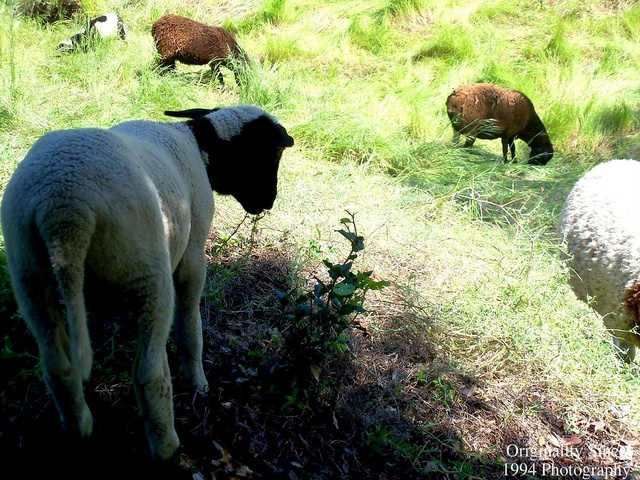Describe the objects in this image and their specific colors. I can see sheep in olive, black, gray, and blue tones, sheep in olive, white, gray, darkgray, and darkgreen tones, sheep in olive, black, and gray tones, sheep in olive, maroon, gray, and black tones, and sheep in olive, ivory, khaki, and lightgreen tones in this image. 